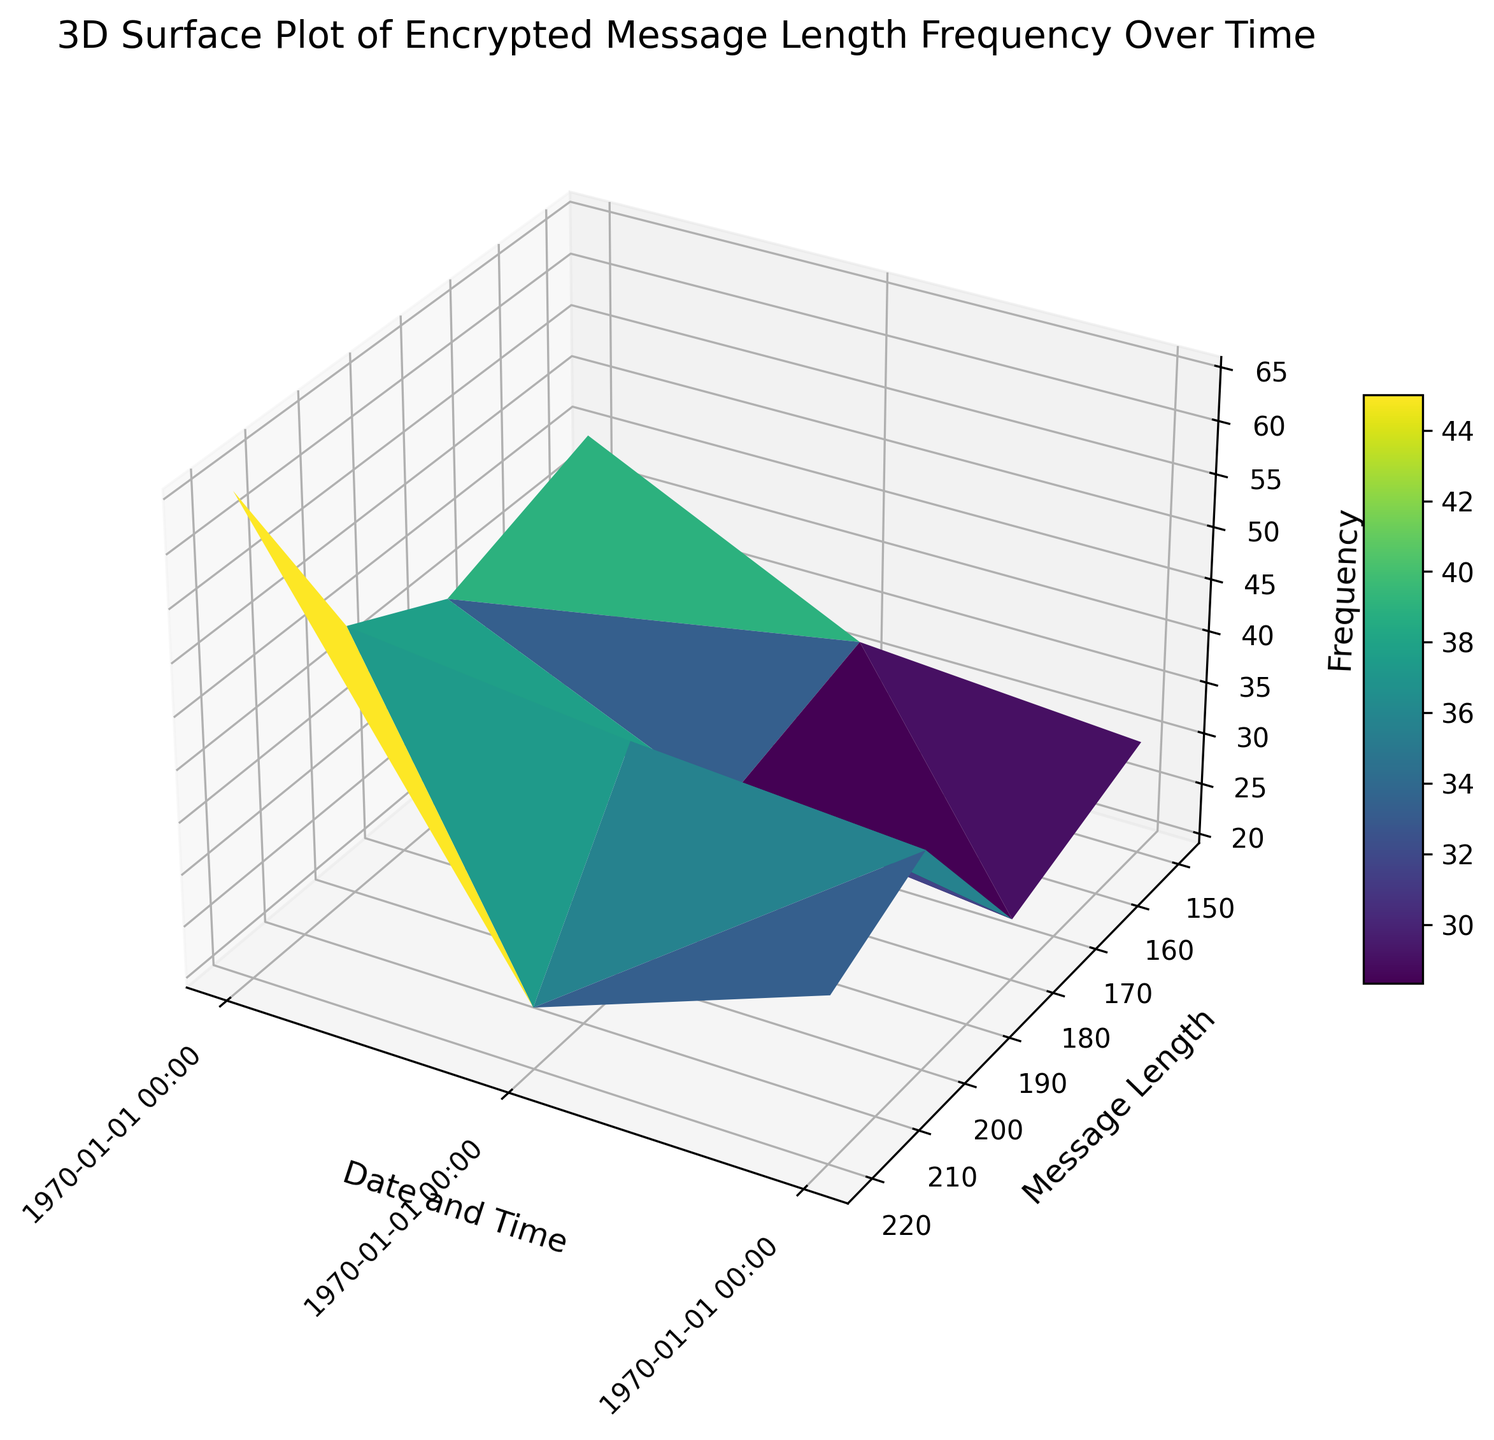What is the highest frequency recorded for any message length on October 1st, 2023? Identify all the data points for October 1st, 2023, then find the highest value on the Z-axis (Frequency) for any message length. The maximum value is 60 for message length 220 at 11:00 AM.
Answer: 60 Which date and time saw the longest messages with the highest frequency? Look for the peak point on the surface plot along the Y-axis (Message Length) and Z-axis (Frequency). The highest frequency for the longest messages (220) appears at 07:00 AM on October 3rd, 2023, with a frequency of 65.
Answer: 07:00 AM on October 3rd, 2023 Comparing 02:00 AM on October 1st and 02:00 AM on October 3rd, which had a higher frequency? Extract the frequency values for message lengths at 02:00 AM on October 1st and 02:00 AM on October 3rd from the Z-axis. October 1st has a frequency of 40, while October 3rd has a frequency of 38.
Answer: October 1st What is the average frequency of message lengths for 200 over the entire period? List all frequencies corresponding to the message length 200: 40, 45, 48, 41, 45, 40, 42, 41, 35, 32, 44, 50, 38, 55, 45, 46. Sum these values (723) and divide by the total count (16).
Answer: 45.2 How does the frequency of 150 message length change from the beginning to the end of October 2nd? Note the frequency of 150 at the start (00:00, 32) and end (23:00, 45) of October 2nd. Calculate the change: 45 - 32. The frequency increases by 13.
Answer: Increases by 13 Is the frequency of messages with length 180 higher at 09:00 on October 2nd or 09:00 on October 3rd? Compare the frequencies at 09:00 on both days: 55 on October 2nd and 40 on October 3rd.
Answer: October 2nd Which message length has the most varying frequency over the observed period? Assess the range of frequencies for each message length by finding the difference between their maximum and minimum frequencies. Measure the highest range. Message length 220 has the most variance, varying from 25 to 65.
Answer: 220 